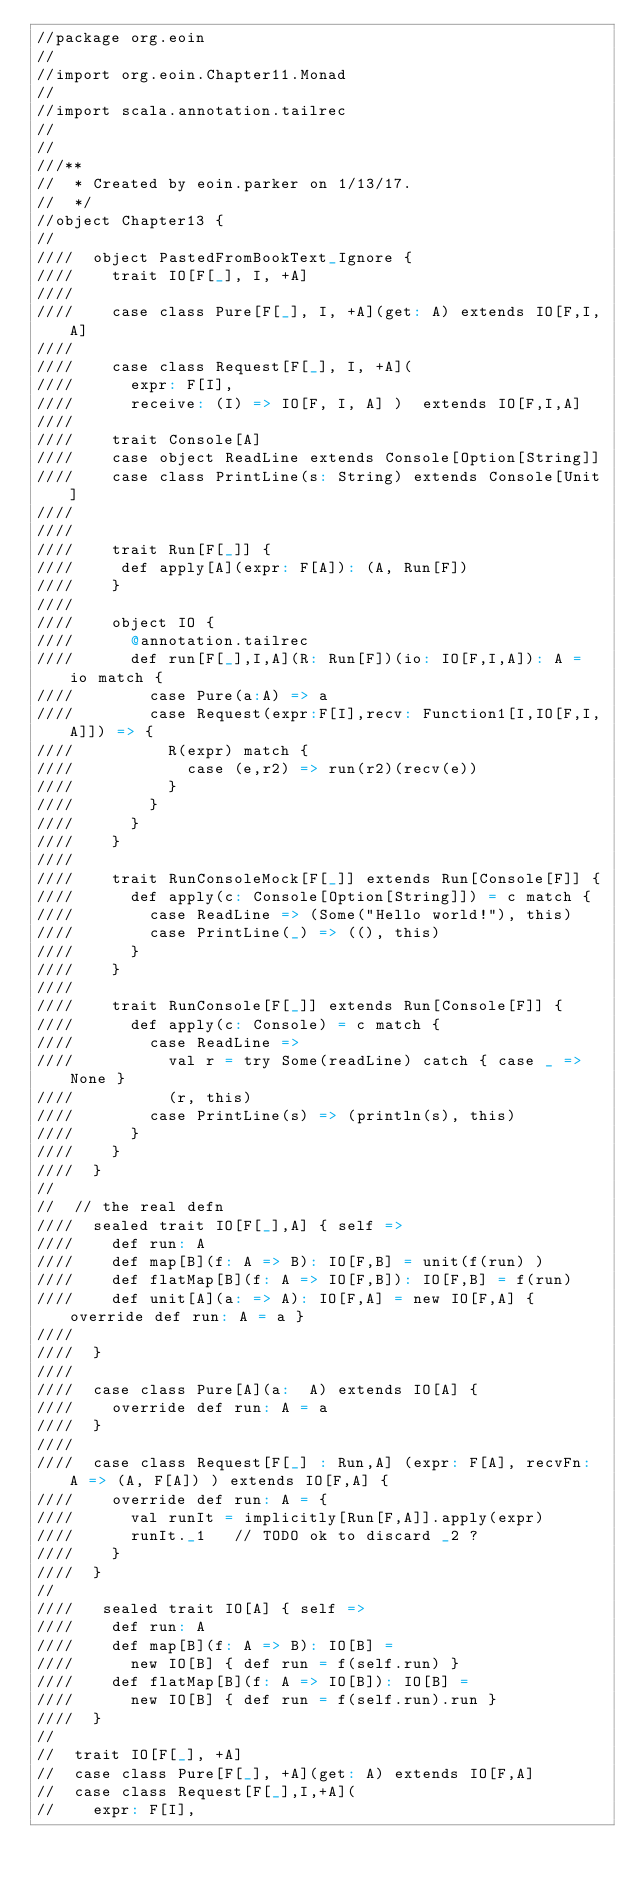<code> <loc_0><loc_0><loc_500><loc_500><_Scala_>//package org.eoin
//
//import org.eoin.Chapter11.Monad
//
//import scala.annotation.tailrec
//
//
///**
//  * Created by eoin.parker on 1/13/17.
//  */
//object Chapter13 {
//
////  object PastedFromBookText_Ignore {
////    trait IO[F[_], I, +A]
////
////    case class Pure[F[_], I, +A](get: A) extends IO[F,I,A]
////
////    case class Request[F[_], I, +A](
////      expr: F[I],
////      receive: (I) => IO[F, I, A] )  extends IO[F,I,A]
////
////    trait Console[A]
////    case object ReadLine extends Console[Option[String]]
////    case class PrintLine(s: String) extends Console[Unit]
////
////
////    trait Run[F[_]] {
////     def apply[A](expr: F[A]): (A, Run[F])
////    }
////
////    object IO {
////      @annotation.tailrec
////      def run[F[_],I,A](R: Run[F])(io: IO[F,I,A]): A = io match {
////        case Pure(a:A) => a
////        case Request(expr:F[I],recv: Function1[I,IO[F,I,A]]) => {
////          R(expr) match {
////            case (e,r2) => run(r2)(recv(e))
////          }
////        }
////      }
////    }
////
////    trait RunConsoleMock[F[_]] extends Run[Console[F]] {
////      def apply(c: Console[Option[String]]) = c match {
////        case ReadLine => (Some("Hello world!"), this)
////        case PrintLine(_) => ((), this)
////      }
////    }
////
////    trait RunConsole[F[_]] extends Run[Console[F]] {
////      def apply(c: Console) = c match {
////        case ReadLine =>
////          val r = try Some(readLine) catch { case _ => None }
////          (r, this)
////        case PrintLine(s) => (println(s), this)
////      }
////    }
////  }
//
//  // the real defn
////  sealed trait IO[F[_],A] { self =>
////    def run: A
////    def map[B](f: A => B): IO[F,B] = unit(f(run) )
////    def flatMap[B](f: A => IO[F,B]): IO[F,B] = f(run)
////    def unit[A](a: => A): IO[F,A] = new IO[F,A] { override def run: A = a }
////
////  }
////
////  case class Pure[A](a:  A) extends IO[A] {
////    override def run: A = a
////  }
////
////  case class Request[F[_] : Run,A] (expr: F[A], recvFn: A => (A, F[A]) ) extends IO[F,A] {
////    override def run: A = {
////      val runIt = implicitly[Run[F,A]].apply(expr)
////      runIt._1   // TODO ok to discard _2 ?
////    }
////  }
//
////   sealed trait IO[A] { self =>
////    def run: A
////    def map[B](f: A => B): IO[B] =
////      new IO[B] { def run = f(self.run) }
////    def flatMap[B](f: A => IO[B]): IO[B] =
////      new IO[B] { def run = f(self.run).run }
////  }
//
//  trait IO[F[_], +A]
//  case class Pure[F[_], +A](get: A) extends IO[F,A]
//  case class Request[F[_],I,+A](
//    expr: F[I],</code> 